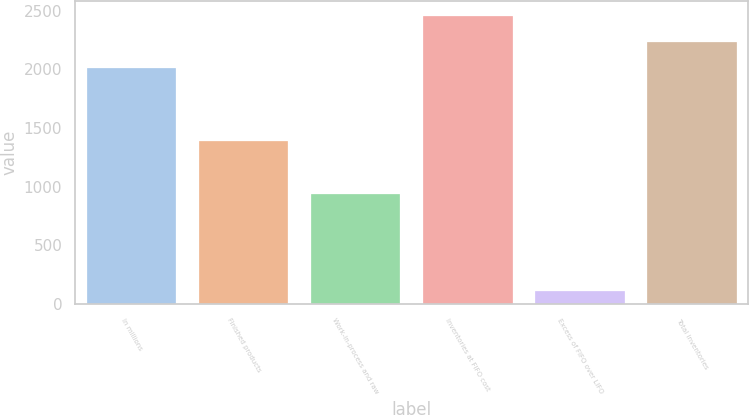<chart> <loc_0><loc_0><loc_500><loc_500><bar_chart><fcel>In millions<fcel>Finished products<fcel>Work-in-process and raw<fcel>Inventories at FIFO cost<fcel>Excess of FIFO over LIFO<fcel>Total inventories<nl><fcel>2012<fcel>1393<fcel>939<fcel>2456.2<fcel>111<fcel>2234.1<nl></chart> 